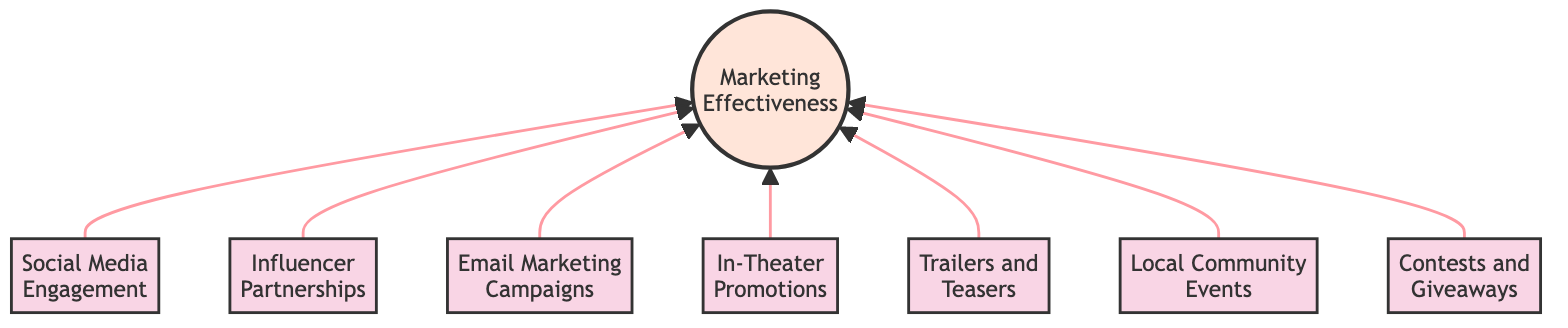What are the main nodes in this flowchart? The main nodes in the flowchart are the elements representing various marketing strategies: Social Media Engagement, Influencer Partnerships, Email Marketing Campaigns, In-Theater Promotions, Trailers and Teasers, Local Community Events, and Contests and Giveaways.
Answer: Social Media Engagement, Influencer Partnerships, Email Marketing Campaigns, In-Theater Promotions, Trailers and Teasers, Local Community Events, Contests and Giveaways How many nodes are present in the diagram? By counting all the individual elements listed in the diagram, including the Marketing Effectiveness node, there are a total of 8 nodes.
Answer: 8 Which node is directly linked to Marketing Effectiveness? All nodes (Social Media Engagement, Influencer Partnerships, Email Marketing Campaigns, In-Theater Promotions, Trailers and Teasers, Local Community Events, and Contests and Giveaways) have direct links to the Marketing Effectiveness node.
Answer: All nodes What type of marketing strategy connects Social Media Engagement and the Marketing Effectiveness node? Social Media Engagement is a type of marketing strategy that feeds into the overall Marketing Effectiveness in the diagram, representing engagement on social media platforms.
Answer: Social Media Engagement Which marketing strategy focuses on local involvement? The Local Community Events node pertains to local involvement and engagement, aimed at generating buzz within communities.
Answer: Local Community Events How do Influencer Partnerships contribute to Marketing Effectiveness? Influencer Partnerships connect to Marketing Effectiveness by leveraging influencers' reach and credibility to amplify promotional efforts and engage target audiences.
Answer: Leveraging reach and credibility What is the relationship between Email Marketing Campaigns and Trailers and Teasers? Both Email Marketing Campaigns and Trailers and Teasers are separate marketing strategies that contribute to the same end goal of improving Marketing Effectiveness. There is no direct link between them in the diagram.
Answer: Separate strategies contributing to the same goal What element is centered at the top of the flowchart? The Marketing Effectiveness node is centered at the top of the flowchart, signifying its role as the focal point for evaluating all marketing strategies below it.
Answer: Marketing Effectiveness 